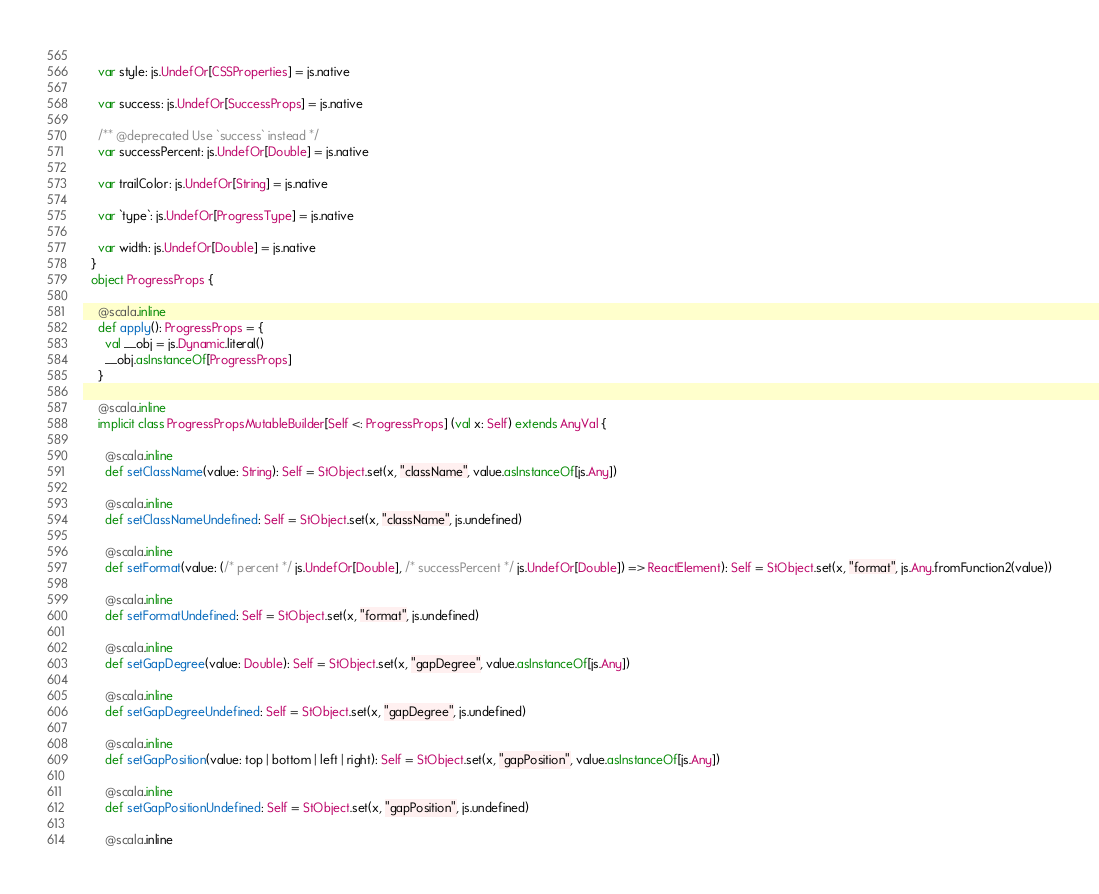Convert code to text. <code><loc_0><loc_0><loc_500><loc_500><_Scala_>    
    var style: js.UndefOr[CSSProperties] = js.native
    
    var success: js.UndefOr[SuccessProps] = js.native
    
    /** @deprecated Use `success` instead */
    var successPercent: js.UndefOr[Double] = js.native
    
    var trailColor: js.UndefOr[String] = js.native
    
    var `type`: js.UndefOr[ProgressType] = js.native
    
    var width: js.UndefOr[Double] = js.native
  }
  object ProgressProps {
    
    @scala.inline
    def apply(): ProgressProps = {
      val __obj = js.Dynamic.literal()
      __obj.asInstanceOf[ProgressProps]
    }
    
    @scala.inline
    implicit class ProgressPropsMutableBuilder[Self <: ProgressProps] (val x: Self) extends AnyVal {
      
      @scala.inline
      def setClassName(value: String): Self = StObject.set(x, "className", value.asInstanceOf[js.Any])
      
      @scala.inline
      def setClassNameUndefined: Self = StObject.set(x, "className", js.undefined)
      
      @scala.inline
      def setFormat(value: (/* percent */ js.UndefOr[Double], /* successPercent */ js.UndefOr[Double]) => ReactElement): Self = StObject.set(x, "format", js.Any.fromFunction2(value))
      
      @scala.inline
      def setFormatUndefined: Self = StObject.set(x, "format", js.undefined)
      
      @scala.inline
      def setGapDegree(value: Double): Self = StObject.set(x, "gapDegree", value.asInstanceOf[js.Any])
      
      @scala.inline
      def setGapDegreeUndefined: Self = StObject.set(x, "gapDegree", js.undefined)
      
      @scala.inline
      def setGapPosition(value: top | bottom | left | right): Self = StObject.set(x, "gapPosition", value.asInstanceOf[js.Any])
      
      @scala.inline
      def setGapPositionUndefined: Self = StObject.set(x, "gapPosition", js.undefined)
      
      @scala.inline</code> 